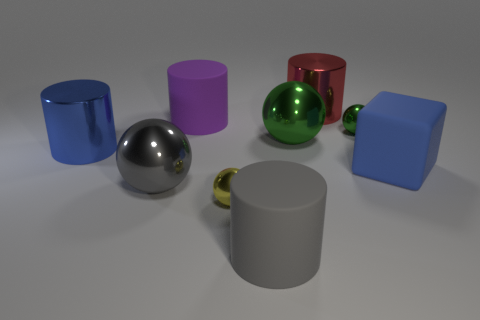Is there a tiny red cylinder that has the same material as the big green object?
Offer a terse response. No. What shape is the large thing that is both behind the big gray rubber cylinder and in front of the blue rubber thing?
Provide a short and direct response. Sphere. What number of small things are either gray shiny things or green rubber objects?
Your answer should be compact. 0. What is the big gray cylinder made of?
Provide a succinct answer. Rubber. How many other things are the same shape as the small green metallic thing?
Keep it short and to the point. 3. The purple matte cylinder has what size?
Offer a terse response. Large. How big is the cylinder that is in front of the purple rubber object and to the left of the yellow sphere?
Offer a terse response. Large. The big object right of the red cylinder has what shape?
Provide a short and direct response. Cube. Does the small yellow sphere have the same material as the big gray thing that is in front of the yellow shiny thing?
Give a very brief answer. No. Is the shape of the big gray metal thing the same as the red thing?
Give a very brief answer. No. 